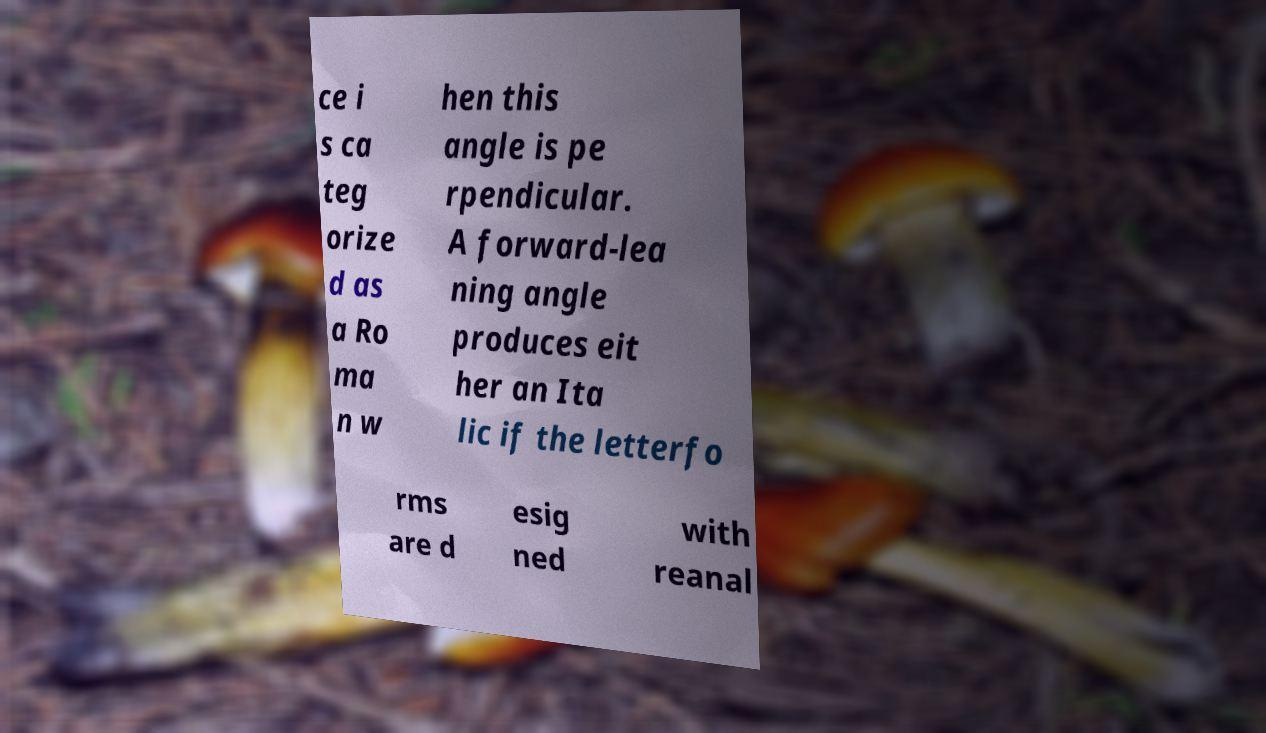For documentation purposes, I need the text within this image transcribed. Could you provide that? ce i s ca teg orize d as a Ro ma n w hen this angle is pe rpendicular. A forward-lea ning angle produces eit her an Ita lic if the letterfo rms are d esig ned with reanal 